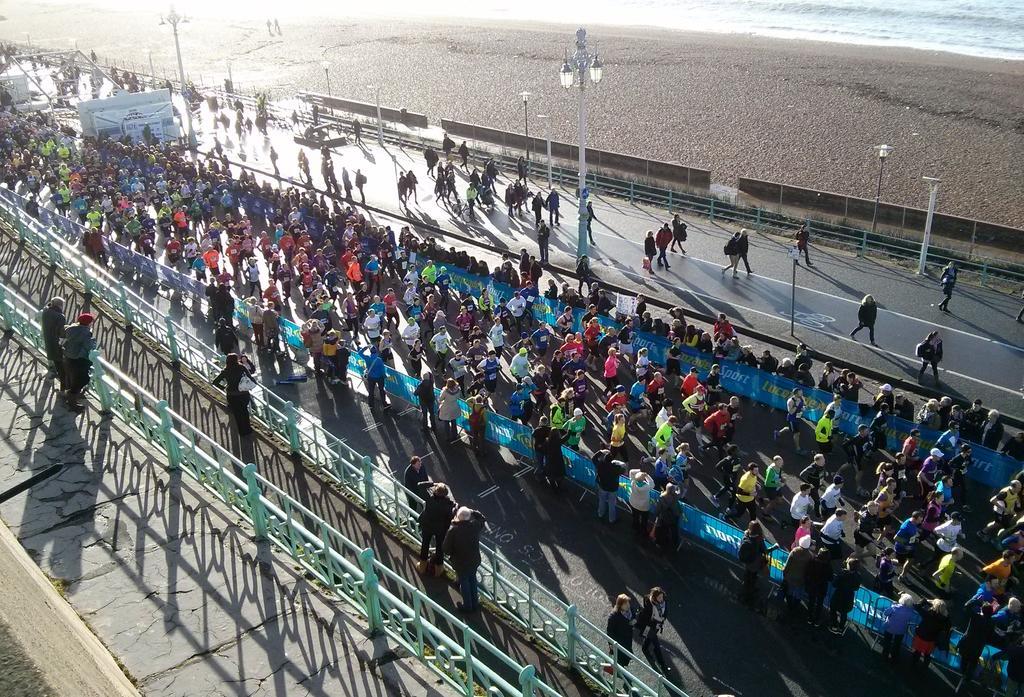How would you summarize this image in a sentence or two? In the middle of the picture, we see many people are walking on the road. Beside them, we see the blue color boards with some text written on it. Beside the boards, we see many people are standing. On the left side, we see the bridges and the railing and many people are standing beside the railing. In the background, we see street lights and people walking on the road. At the top, we see water and the sand. 